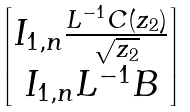<formula> <loc_0><loc_0><loc_500><loc_500>\begin{bmatrix} I _ { 1 , n } \frac { L ^ { - 1 } C ( z _ { 2 } ) } { \sqrt { z _ { 2 } } } \\ I _ { 1 , n } L ^ { - 1 } B \end{bmatrix}</formula> 